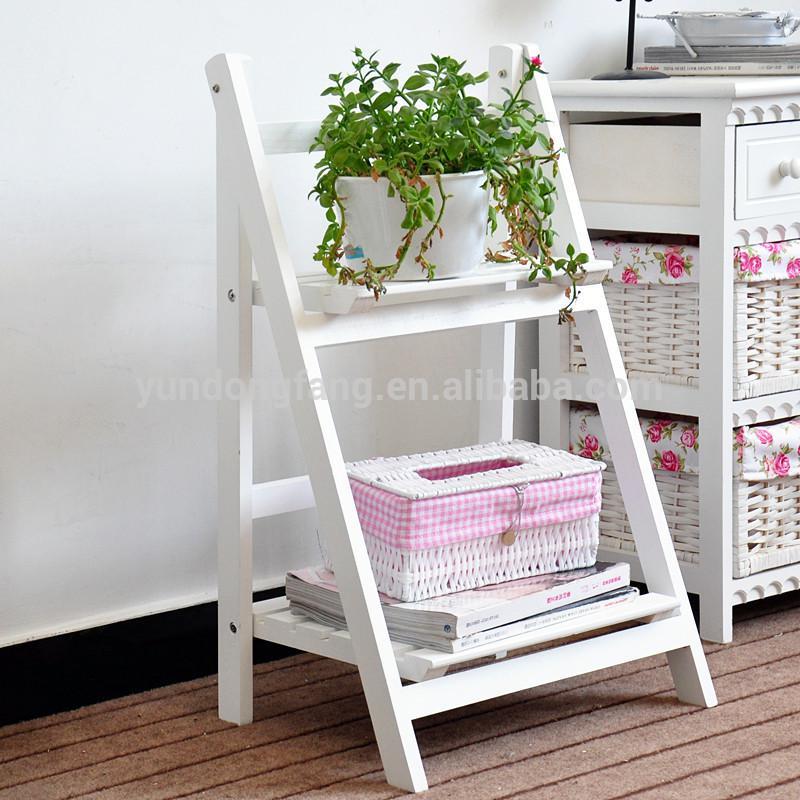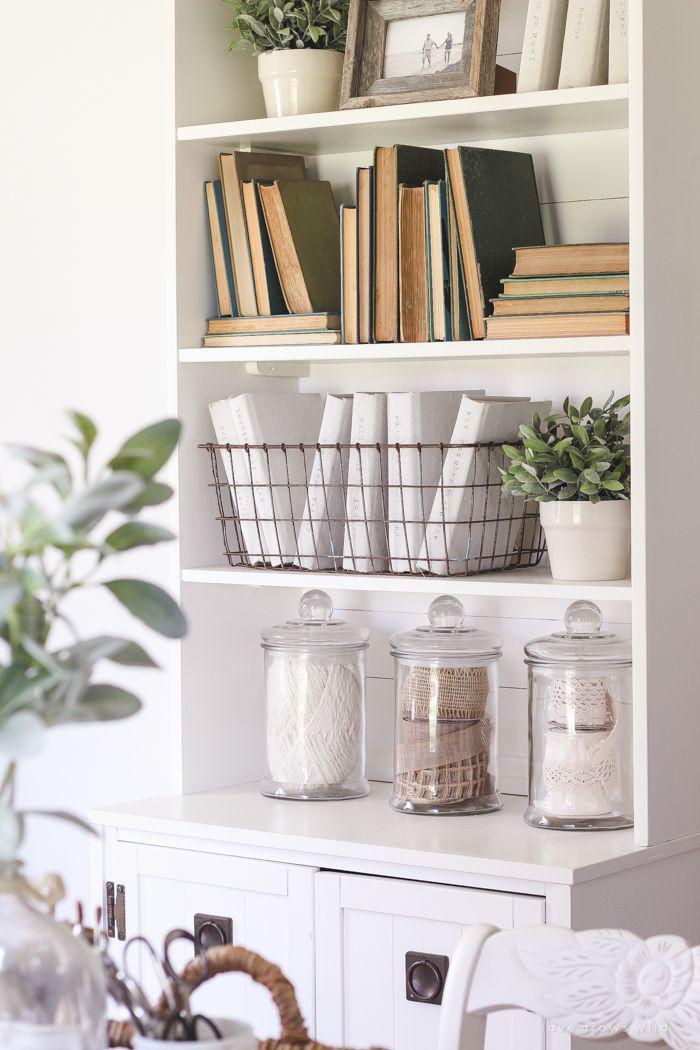The first image is the image on the left, the second image is the image on the right. For the images displayed, is the sentence "At least one image shows floating brown shelves, and all images include at least one potted green plant." factually correct? Answer yes or no. No. 